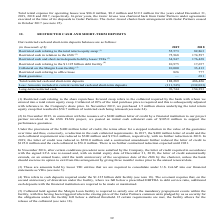According to Golar Lng's financial document, What does restricted cash relating to the share repurchase forward swap represent? Collateral required by the bank with whom we entered into a total return equity swap. The document states: "o the share repurchase forward swap refers to the collateral required by the bank with whom we entered into a total return equity swap. Collateral of ..." Also, How much letter of credit was issued by the financial institution in 2015? According to the financial document, $400 million. The relevant text states: "ovember 2015, in connection with the issuance of a $400 million letter of credit by a financial institution to our project partner involved in the Hilli FLNG projec..." Also, In which years was the restricted cash and short-term deposits recorded for? The document shows two values: 2019 and 2018. From the document: "(in thousands of $) 2019 2018 Restricted cash relating to the total return equity swap (1) 55,573 82,863 Restricted cash in (in thousands of $) 2019 2..." Additionally, In which year was the restricted cash relating to office lease higher? According to the financial document, 2019. The relevant text states: "(in thousands of $) 2019 2018 Restricted cash relating to the total return equity swap (1) 55,573 82,863 Restricted cash in..." Also, can you calculate: What was the change in collateral on the Margin Loan facility between 2018 and 2019? Based on the calculation: 10,000 - 33,413 , the result is -23413 (in thousands). This is based on the information: "17,657 Collateral on the Margin Loan facility (5) 10,000 33,413 Restricted cash relating to office lease 826 777 Bank guarantee — 691 Total restricted cash Collateral on the Margin Loan facility (5) 1..." The key data points involved are: 10,000, 33,413. Also, can you calculate: What was the percentage change in restricted cash in relation to the Hilli between 2018 and 2019? To answer this question, I need to perform calculations using the financial data. The calculation is: (75,968 - 174,597)/174,597 , which equals -56.49 (percentage). This is based on the information: ",863 Restricted cash in relation to the Hilli (2) 75,968 174,597 Restricted cash and short-term deposits held by lessor VIEs (3) 34,947 176,428 Restricted c stricted cash in relation to the Hilli (2) ..." The key data points involved are: 174,597, 75,968. 